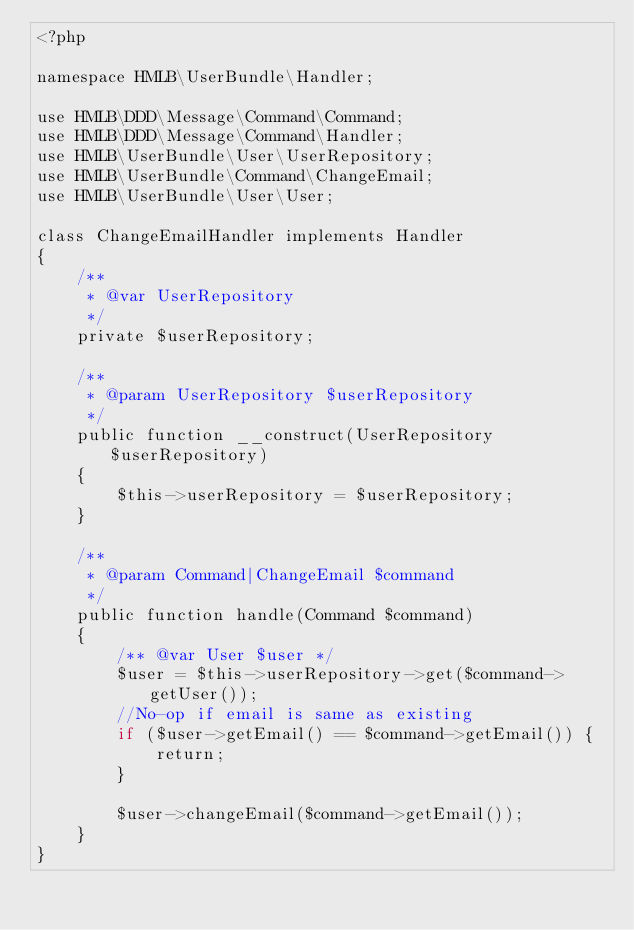<code> <loc_0><loc_0><loc_500><loc_500><_PHP_><?php

namespace HMLB\UserBundle\Handler;

use HMLB\DDD\Message\Command\Command;
use HMLB\DDD\Message\Command\Handler;
use HMLB\UserBundle\User\UserRepository;
use HMLB\UserBundle\Command\ChangeEmail;
use HMLB\UserBundle\User\User;

class ChangeEmailHandler implements Handler
{
    /**
     * @var UserRepository
     */
    private $userRepository;

    /**
     * @param UserRepository $userRepository
     */
    public function __construct(UserRepository $userRepository)
    {
        $this->userRepository = $userRepository;
    }

    /**
     * @param Command|ChangeEmail $command
     */
    public function handle(Command $command)
    {
        /** @var User $user */
        $user = $this->userRepository->get($command->getUser());
        //No-op if email is same as existing
        if ($user->getEmail() == $command->getEmail()) {
            return;
        }

        $user->changeEmail($command->getEmail());
    }
}
</code> 